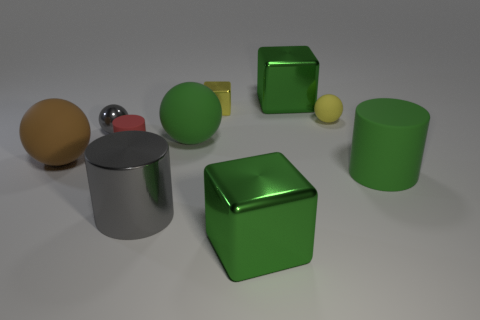Is the tiny metallic block the same color as the small matte sphere?
Your answer should be compact. Yes. There is a large brown object that is the same shape as the yellow matte thing; what is it made of?
Provide a short and direct response. Rubber. What is the shape of the green rubber object that is the same size as the green ball?
Offer a very short reply. Cylinder. Is the material of the tiny sphere that is to the right of the large gray cylinder the same as the small gray sphere that is left of the green matte ball?
Give a very brief answer. No. There is a green cylinder that is the same material as the large brown ball; what size is it?
Provide a short and direct response. Large. There is a gray object on the right side of the red matte thing; what shape is it?
Make the answer very short. Cylinder. Does the large block that is in front of the tiny gray ball have the same color as the block behind the small yellow metal object?
Offer a very short reply. Yes. What is the size of the shiny cylinder that is the same color as the shiny ball?
Give a very brief answer. Large. Is there a matte cylinder?
Offer a terse response. Yes. What is the shape of the yellow object right of the big cube that is right of the big green thing in front of the large gray shiny object?
Your response must be concise. Sphere. 